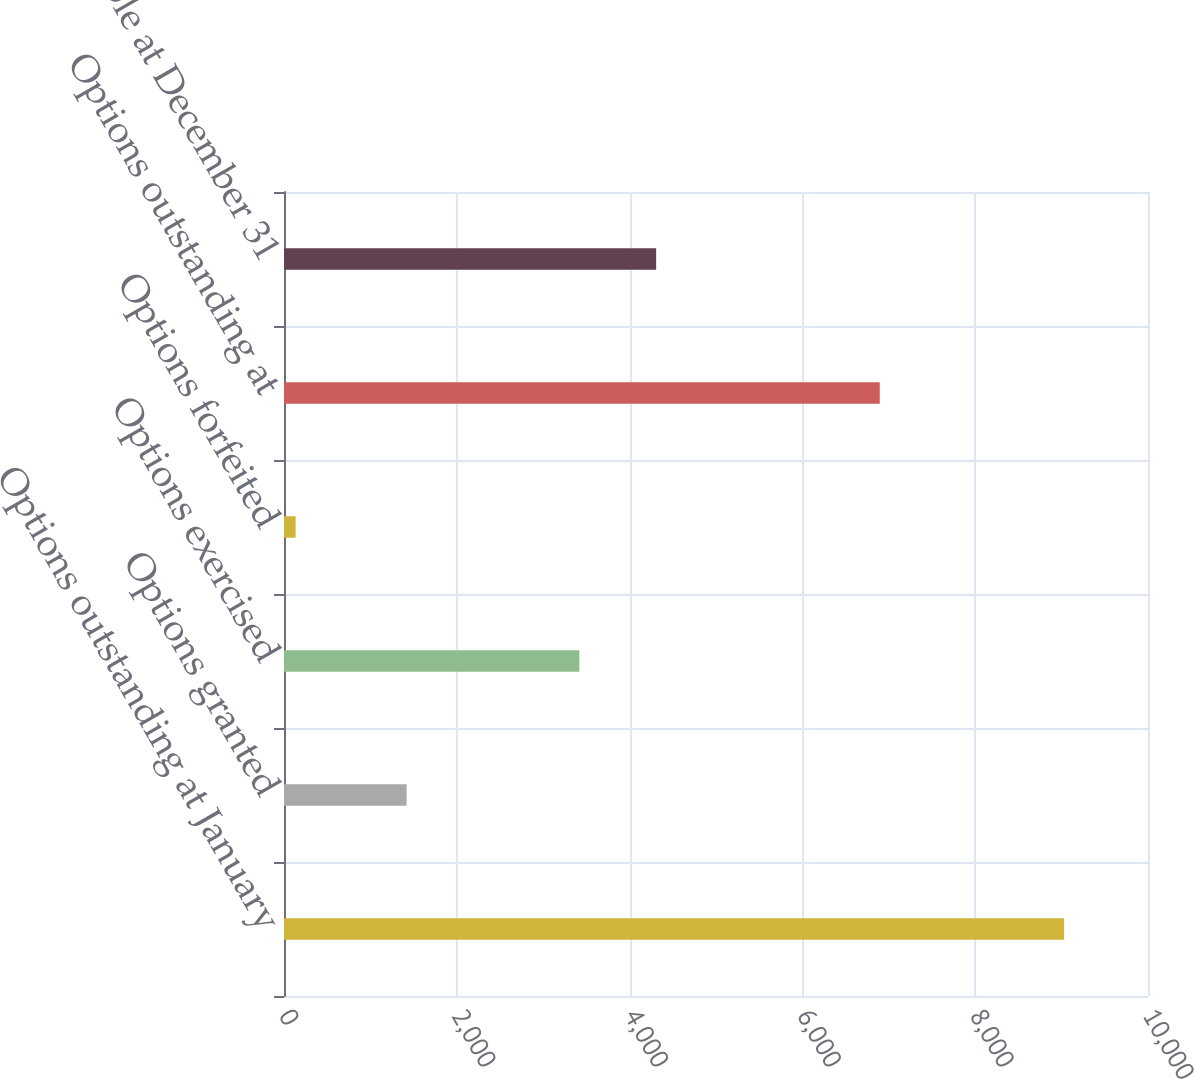<chart> <loc_0><loc_0><loc_500><loc_500><bar_chart><fcel>Options outstanding at January<fcel>Options granted<fcel>Options exercised<fcel>Options forfeited<fcel>Options outstanding at<fcel>Exercisable at December 31<nl><fcel>9029<fcel>1419<fcel>3418<fcel>135<fcel>6895<fcel>4307.4<nl></chart> 